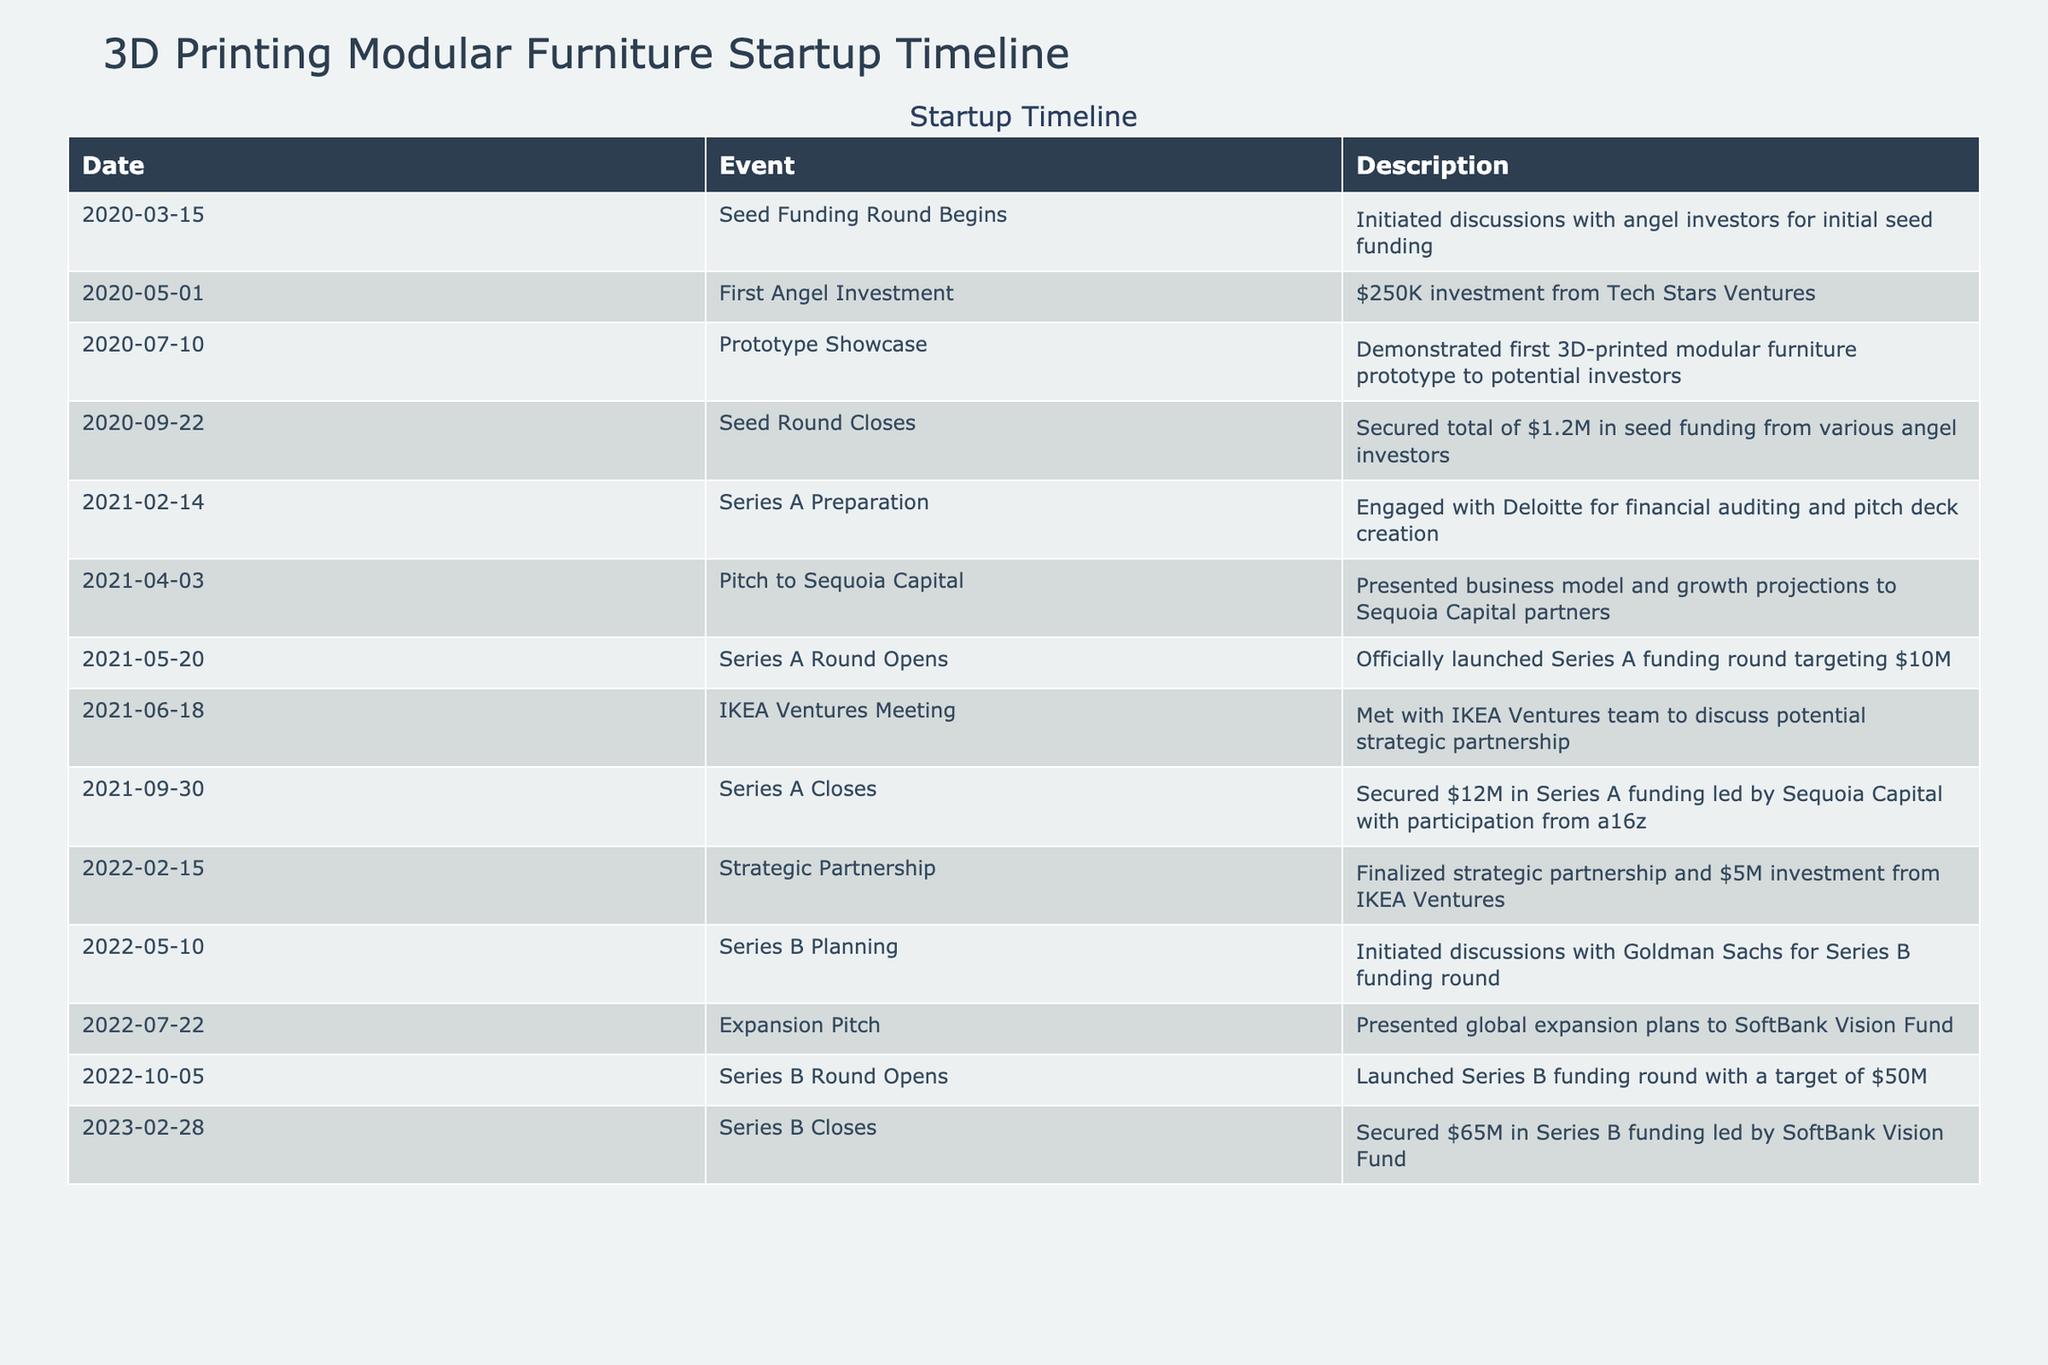What date did the Seed Round close? The Seed Round closed on September 22, 2020, as indicated in the table under the 'Date' column for the respective event.
Answer: September 22, 2020 How much funding was secured in the Series A round? The total funding secured in the Series A round was $12M, based on the entry for the "Series A Closes" event in the table.
Answer: $12M What was the total funding amount secured between Seed and Series A rounds? The Seed funding secured was $1.2M and the Series A funding secured was $12M. Adding these amounts gives $1.2M + $12M = $13.2M.
Answer: $13.2M Did the startup meet with IKEA Ventures before the Series A funding closed? Yes, the startup had a meeting with IKEA Ventures on June 18, 2021, which is before the Series A Closes on September 30, 2021.
Answer: Yes What was the final investment amount from IKEA Ventures? The final investment amount from IKEA Ventures was $5M, as detailed under the "Strategic Partnership" event on February 15, 2022.
Answer: $5M What was the total amount of funding closed in the Series B round? The Series B round closed with a total of $65M, which is mentioned in the "Series B Closes" event on February 28, 2023.
Answer: $65M Which investor was involved in the earliest funding round, and what was the amount? The earliest funding round was the Seed funding, and it involved Tech Stars Ventures, which invested $250K.
Answer: Tech Stars Ventures, $250K How long did the Series B funding round run from opening to closing? The Series B round opened on October 5, 2022, and closed on February 28, 2023. This is a duration of approximately 4 months and 23 days.
Answer: About 4 months and 23 days What event occurred after the Series A Preparation? The event that occurred after Series A Preparation (February 14, 2021) was the "Pitch to Sequoia Capital" on April 3, 2021.
Answer: Pitch to Sequoia Capital 